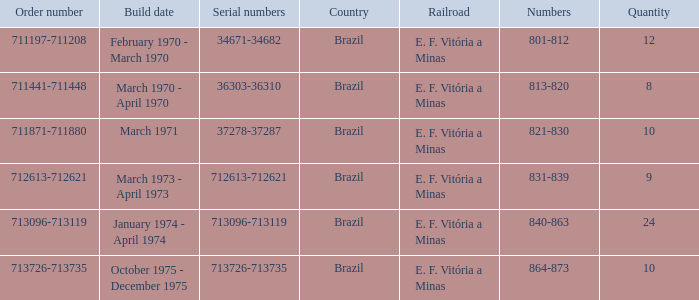Which country has the serial numbers 713096-713119? Brazil. 